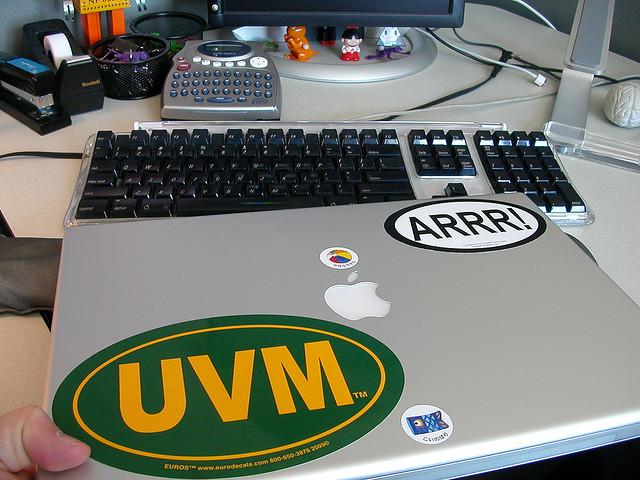What sticker relates to a pirate?
Answer briefly. Arrr!. How many fingers are seen?
Short answer required. 1. What kind of computer is this?
Write a very short answer. Apple. 